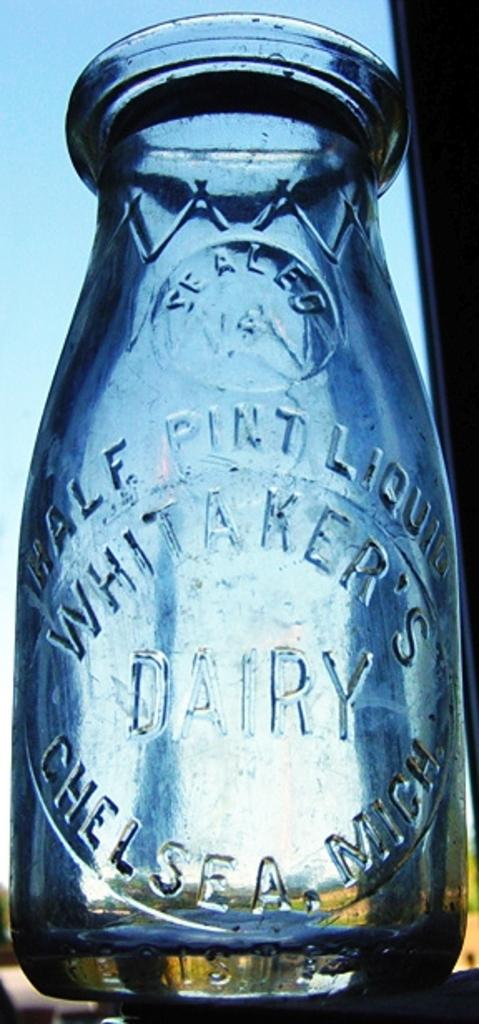<image>
Share a concise interpretation of the image provided. A glass jar is labeled as "Whitaker's Dairy". 